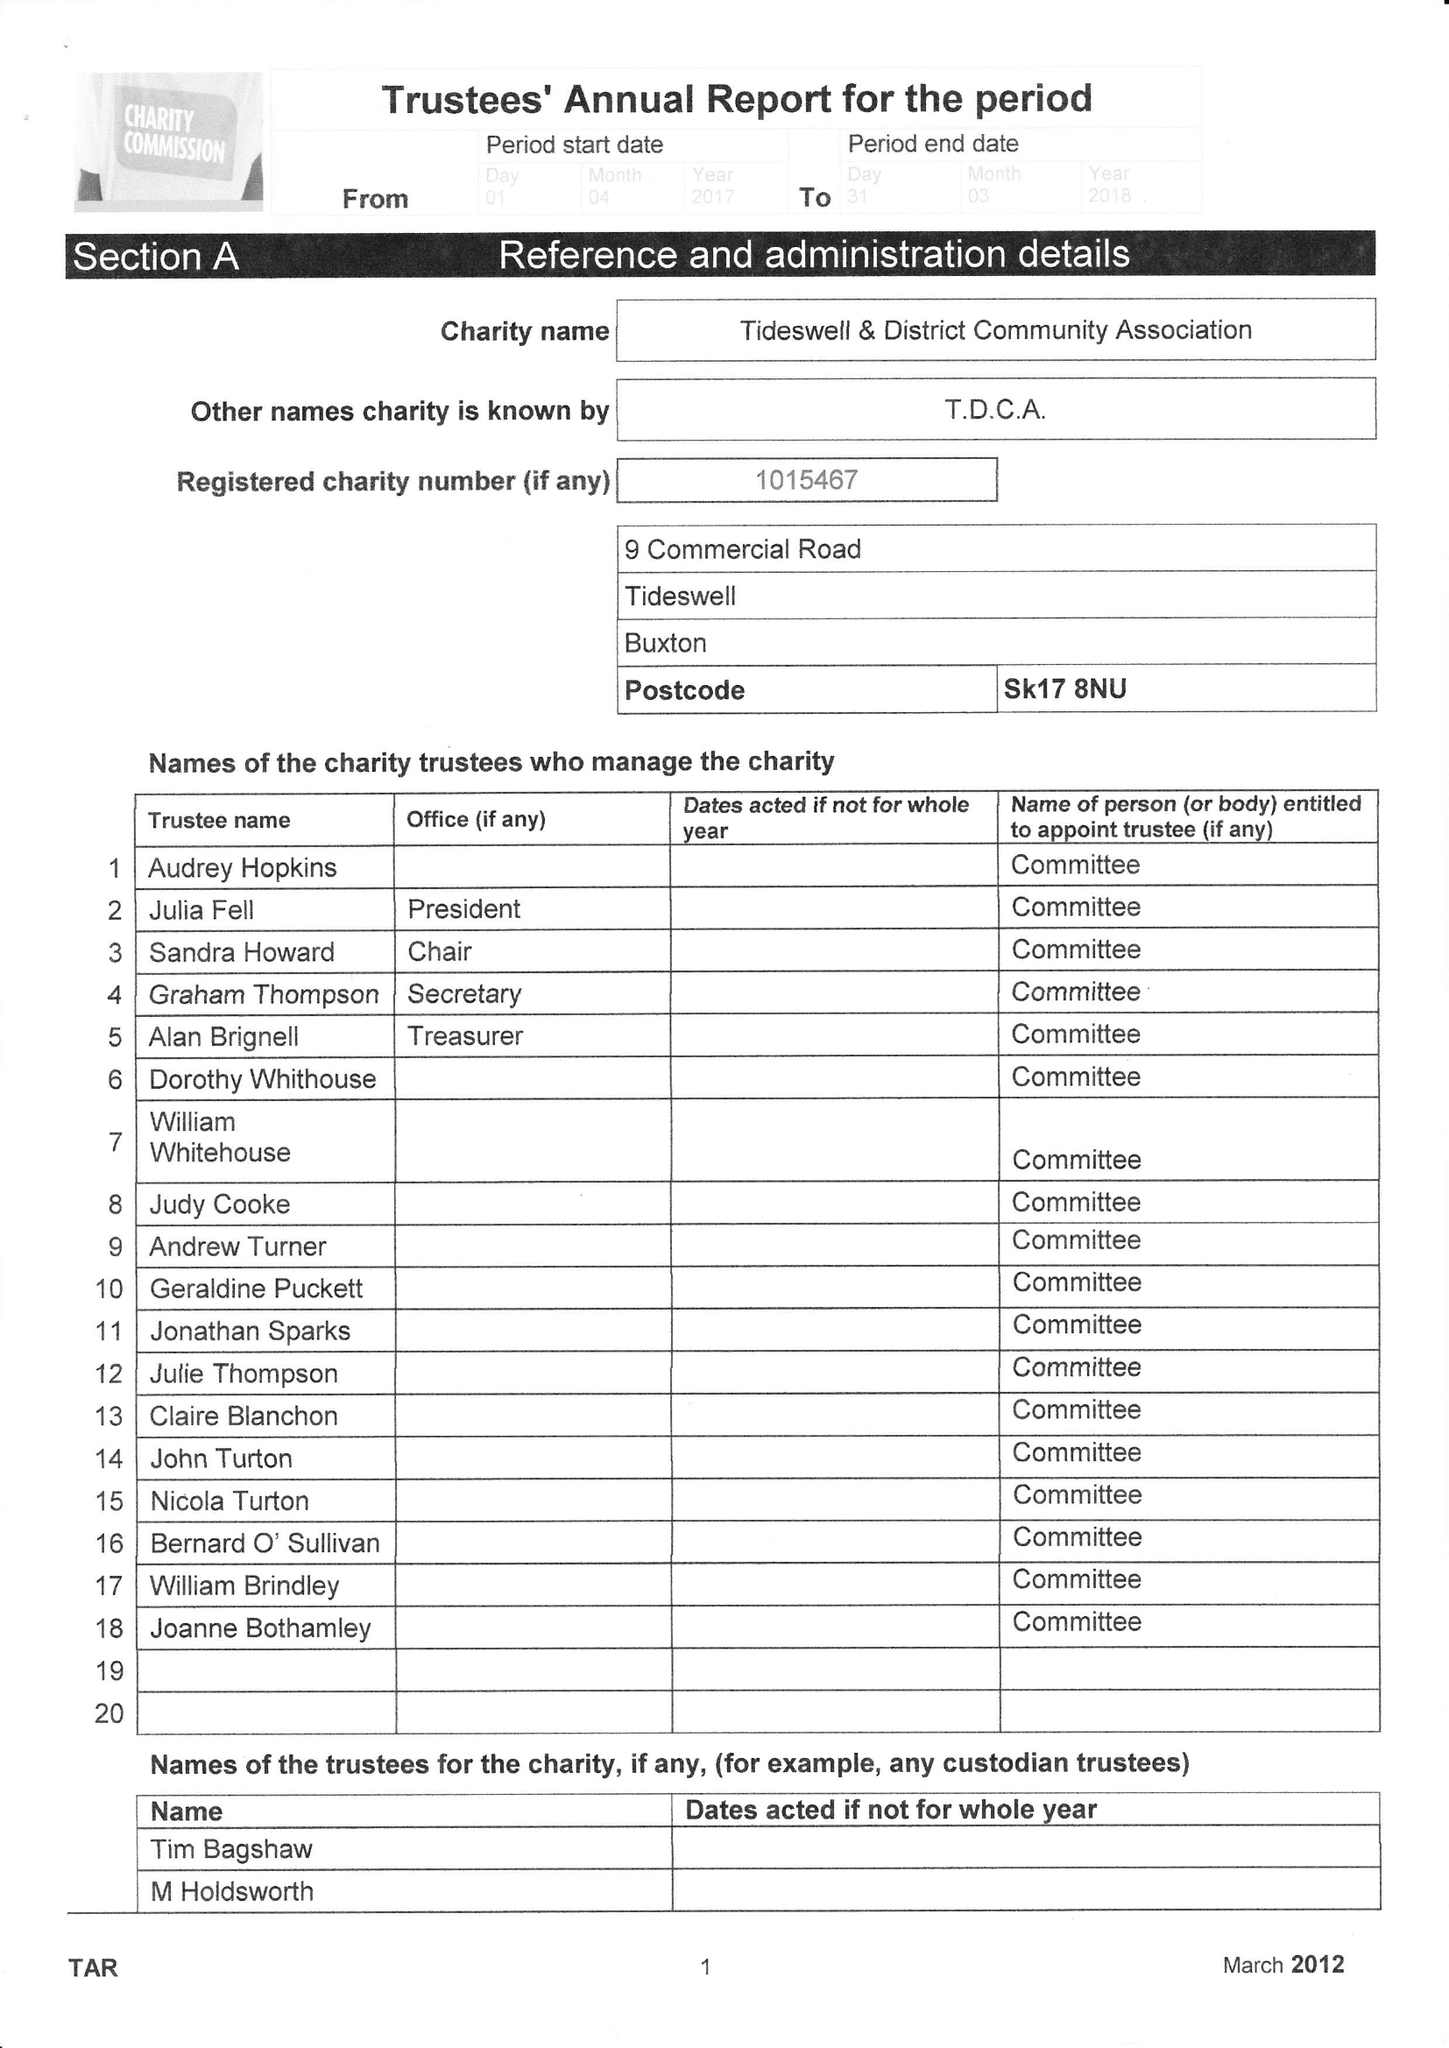What is the value for the address__post_town?
Answer the question using a single word or phrase. BUXTON 